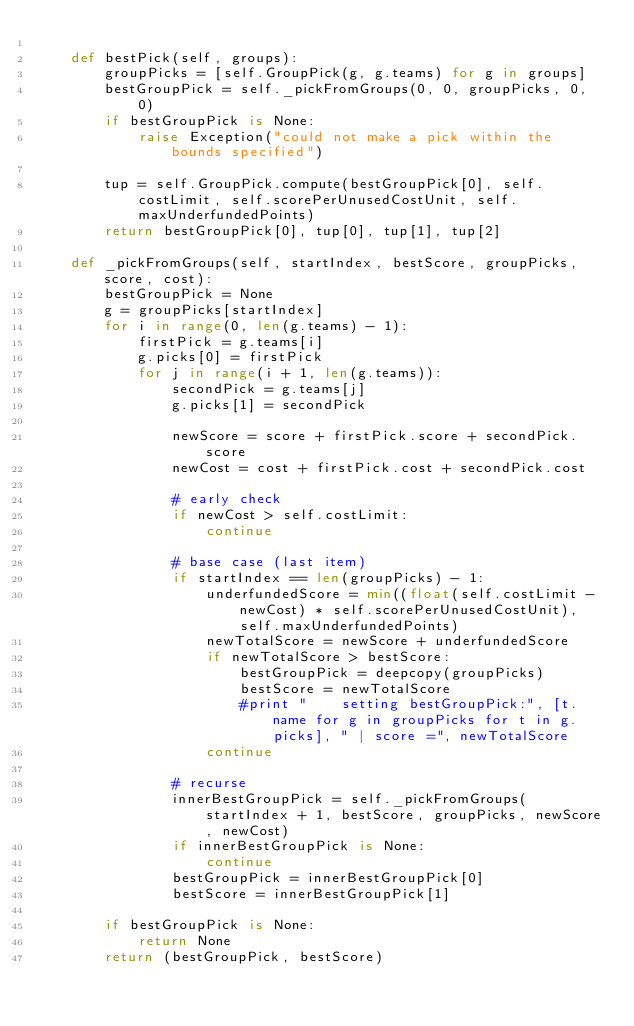Convert code to text. <code><loc_0><loc_0><loc_500><loc_500><_Python_>
    def bestPick(self, groups):
        groupPicks = [self.GroupPick(g, g.teams) for g in groups]
        bestGroupPick = self._pickFromGroups(0, 0, groupPicks, 0, 0)
        if bestGroupPick is None:
            raise Exception("could not make a pick within the bounds specified")

        tup = self.GroupPick.compute(bestGroupPick[0], self.costLimit, self.scorePerUnusedCostUnit, self.maxUnderfundedPoints)
        return bestGroupPick[0], tup[0], tup[1], tup[2]

    def _pickFromGroups(self, startIndex, bestScore, groupPicks, score, cost):
        bestGroupPick = None
        g = groupPicks[startIndex]
        for i in range(0, len(g.teams) - 1):
            firstPick = g.teams[i]
            g.picks[0] = firstPick
            for j in range(i + 1, len(g.teams)):
                secondPick = g.teams[j]
                g.picks[1] = secondPick

                newScore = score + firstPick.score + secondPick.score
                newCost = cost + firstPick.cost + secondPick.cost

                # early check
                if newCost > self.costLimit:
                    continue

                # base case (last item)
                if startIndex == len(groupPicks) - 1:
                    underfundedScore = min((float(self.costLimit - newCost) * self.scorePerUnusedCostUnit), self.maxUnderfundedPoints)
                    newTotalScore = newScore + underfundedScore
                    if newTotalScore > bestScore:
                        bestGroupPick = deepcopy(groupPicks)
                        bestScore = newTotalScore
                        #print "    setting bestGroupPick:", [t.name for g in groupPicks for t in g.picks], " | score =", newTotalScore
                    continue

                # recurse
                innerBestGroupPick = self._pickFromGroups(startIndex + 1, bestScore, groupPicks, newScore, newCost)
                if innerBestGroupPick is None:
                    continue
                bestGroupPick = innerBestGroupPick[0]
                bestScore = innerBestGroupPick[1]

        if bestGroupPick is None:
            return None
        return (bestGroupPick, bestScore)
</code> 